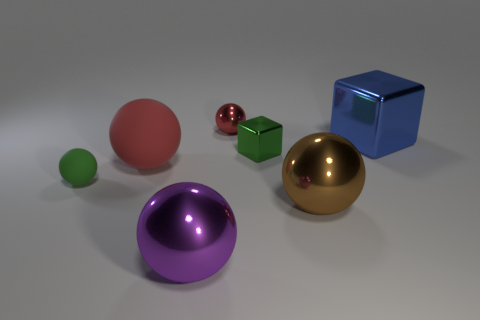There is a brown shiny thing; what shape is it?
Offer a very short reply. Sphere. What number of small purple cylinders are the same material as the blue thing?
Your answer should be very brief. 0. What color is the tiny sphere that is the same material as the large blue cube?
Offer a terse response. Red. There is a ball behind the blue shiny cube; is it the same size as the big blue block?
Your response must be concise. No. What is the color of the big rubber thing that is the same shape as the tiny red thing?
Offer a terse response. Red. What is the shape of the tiny shiny thing that is in front of the big shiny object that is behind the matte ball that is in front of the big red matte ball?
Provide a short and direct response. Cube. Does the big purple object have the same shape as the blue thing?
Your answer should be compact. No. There is a large metallic thing that is on the left side of the red sphere that is right of the big red thing; what is its shape?
Offer a terse response. Sphere. Is there a tiny green thing?
Your answer should be very brief. Yes. There is a large object behind the block to the left of the big brown sphere; how many large objects are in front of it?
Your response must be concise. 3. 